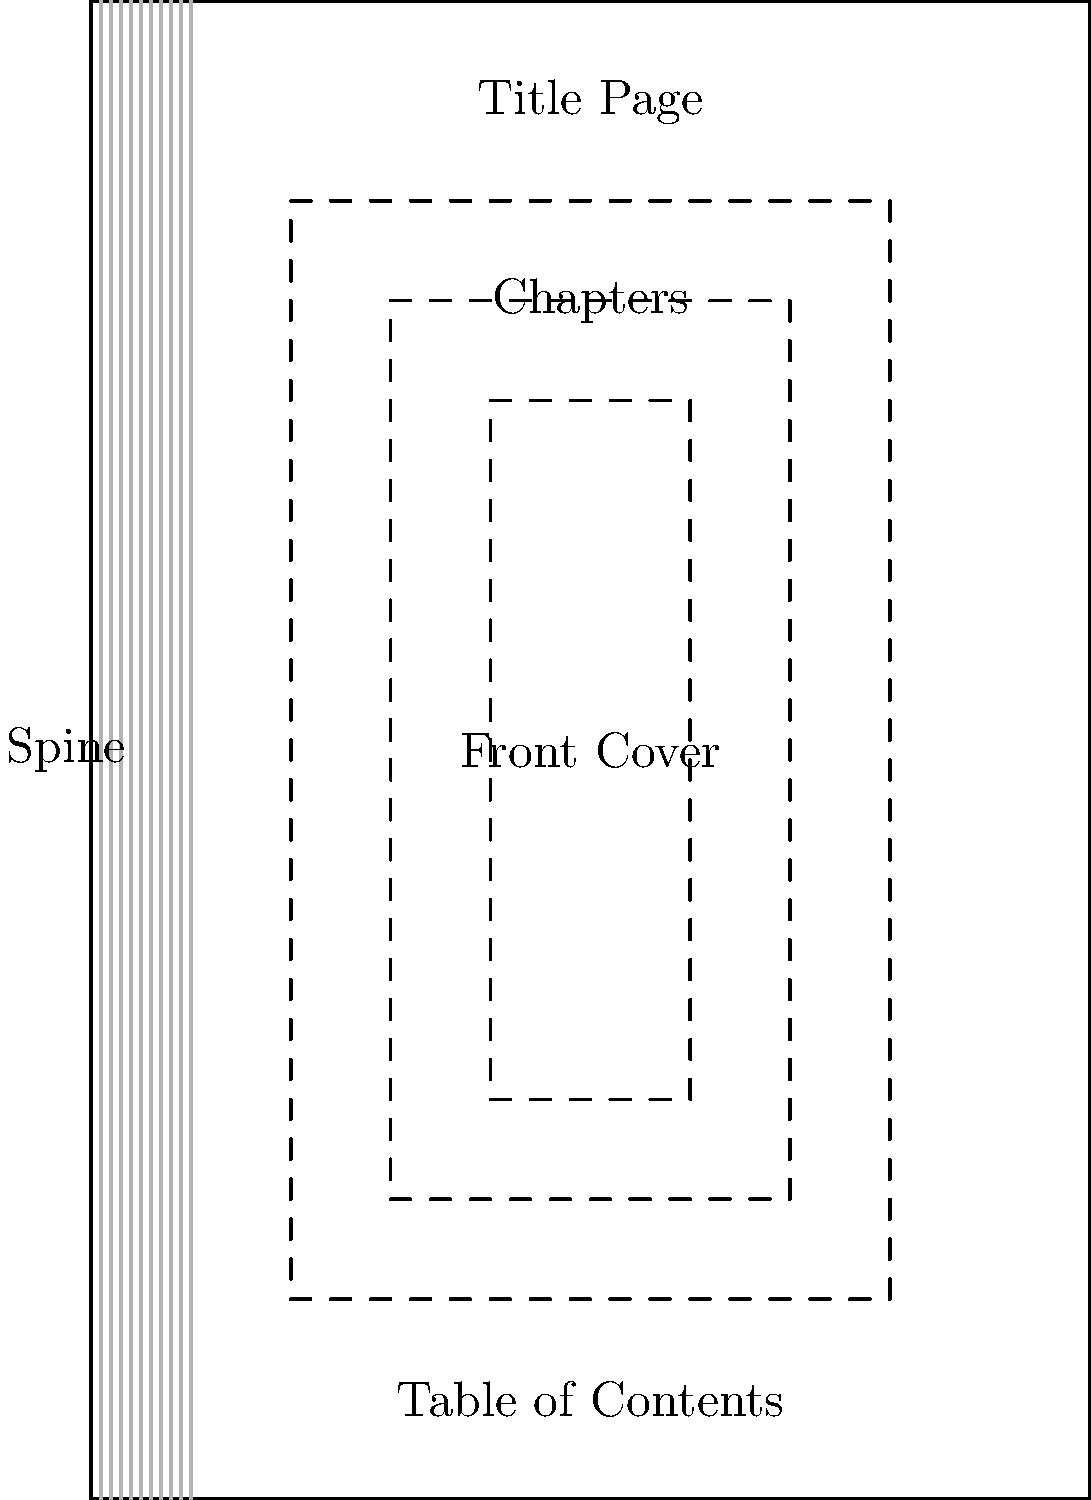Identify the component of a book's structure that typically contains a list of chapter titles and their corresponding page numbers. Which part of the book is this, and why is it important for readers? Let's break this down step-by-step:

1. The diagram shows various components of a book's structure.

2. We can see labels for different parts: Front Cover, Spine, Title Page, Table of Contents, and Chapters.

3. The question asks about a component that lists chapter titles and page numbers.

4. Looking at the diagram, we can see that the "Table of Contents" is represented by a dashed box near the front of the book.

5. The Table of Contents is important for readers because:
   a) It provides an overview of the book's content.
   b) It allows readers to quickly locate specific chapters or sections.
   c) It helps readers understand the book's structure and organization.
   d) It can be used to estimate the length and depth of different topics covered in the book.

6. For a skeptical but curious teenager, the Table of Contents can be particularly useful as it allows them to:
   a) Quickly assess if the book covers topics of interest to them.
   b) Skip to chapters that seem most appealing or relevant.
   c) Get a sense of the book's complexity and depth without having to read it cover-to-cover.

Therefore, the component in question is the Table of Contents, which serves as a valuable tool for navigating the book's content and structure.
Answer: Table of Contents 